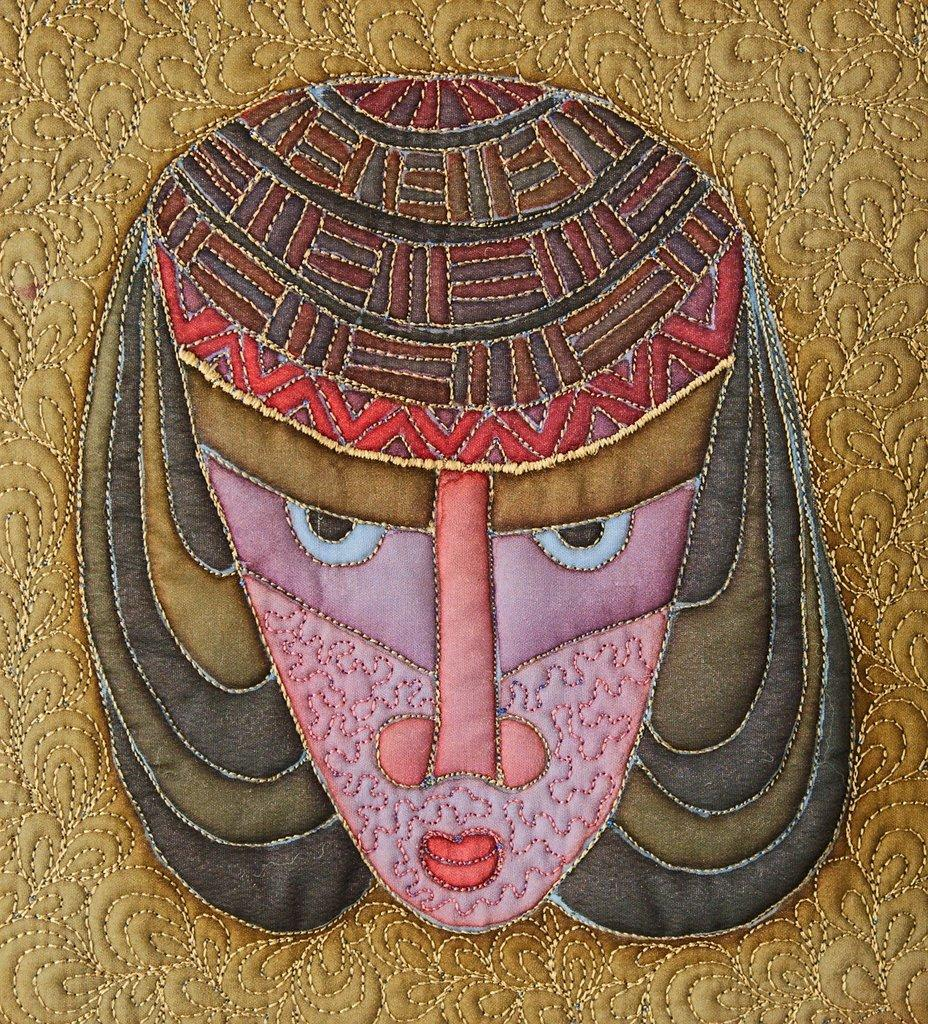What type of craft is visible on the surface in the image? There is thread craft on the surface in the image. Can you see any parks or lakes in the image? There is no mention of parks or lakes in the provided facts, and therefore they cannot be seen in the image. 